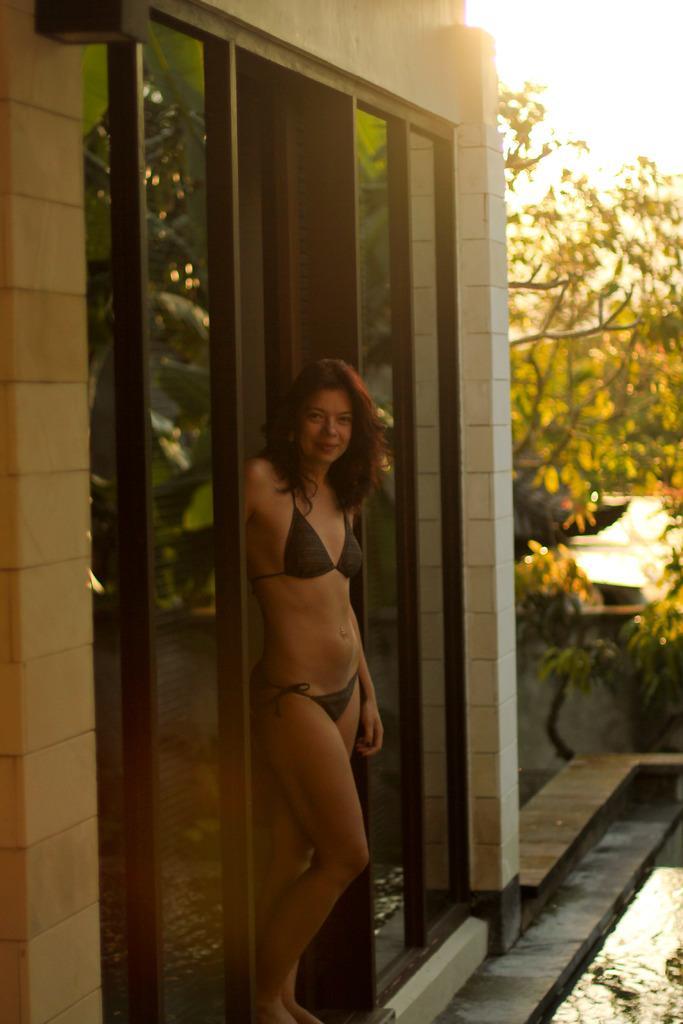How would you summarize this image in a sentence or two? In this picture we can see a woman standing. There is a building and some trees in the background. We can see a glass and water. 